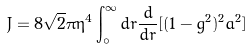Convert formula to latex. <formula><loc_0><loc_0><loc_500><loc_500>J = 8 \sqrt { 2 } \pi \eta ^ { 4 } \int ^ { \infty } _ { \circ } d r \frac { d } { d r } [ ( 1 - g ^ { 2 } ) ^ { 2 } a ^ { 2 } ]</formula> 